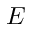<formula> <loc_0><loc_0><loc_500><loc_500>E</formula> 